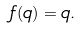Convert formula to latex. <formula><loc_0><loc_0><loc_500><loc_500>f ( q ) = q .</formula> 